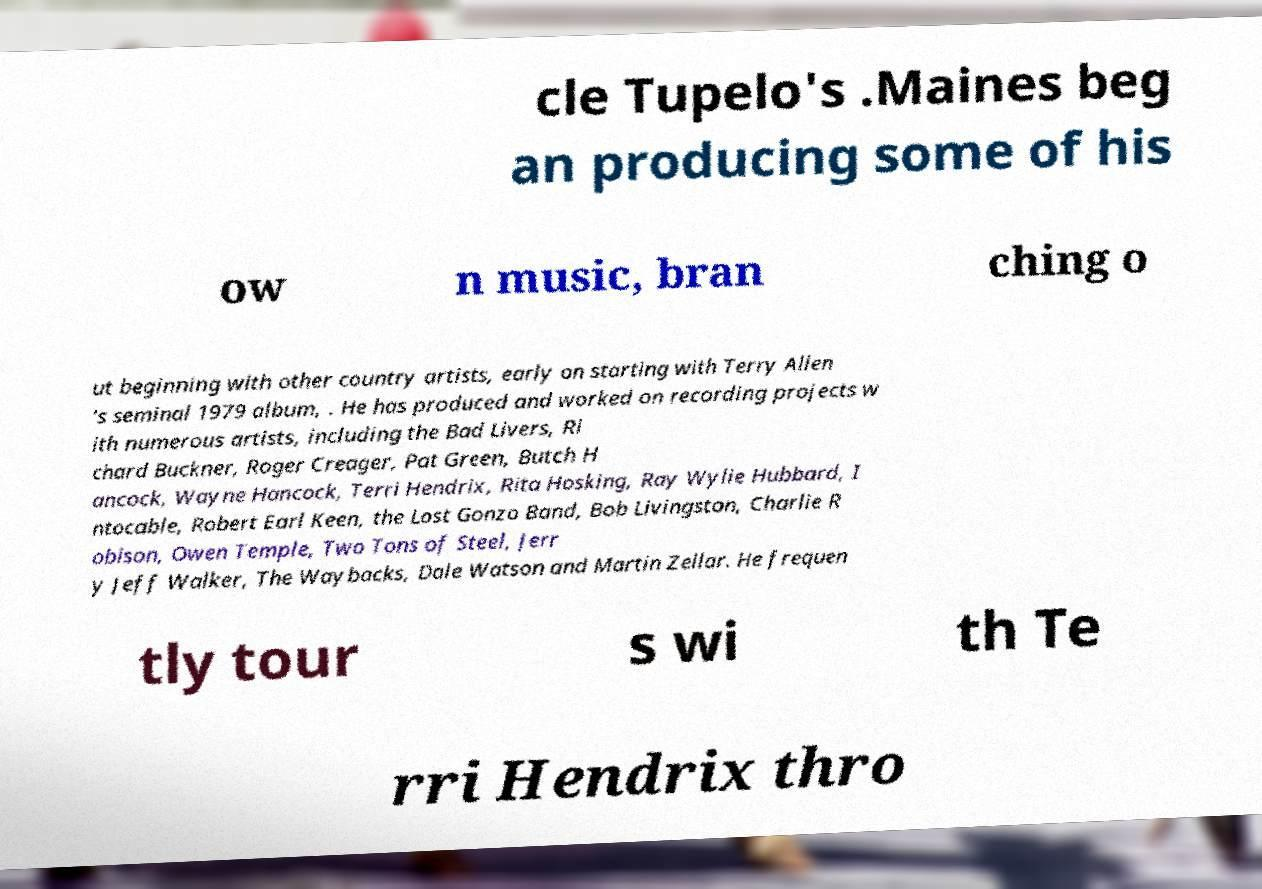What messages or text are displayed in this image? I need them in a readable, typed format. cle Tupelo's .Maines beg an producing some of his ow n music, bran ching o ut beginning with other country artists, early on starting with Terry Allen 's seminal 1979 album, . He has produced and worked on recording projects w ith numerous artists, including the Bad Livers, Ri chard Buckner, Roger Creager, Pat Green, Butch H ancock, Wayne Hancock, Terri Hendrix, Rita Hosking, Ray Wylie Hubbard, I ntocable, Robert Earl Keen, the Lost Gonzo Band, Bob Livingston, Charlie R obison, Owen Temple, Two Tons of Steel, Jerr y Jeff Walker, The Waybacks, Dale Watson and Martin Zellar. He frequen tly tour s wi th Te rri Hendrix thro 